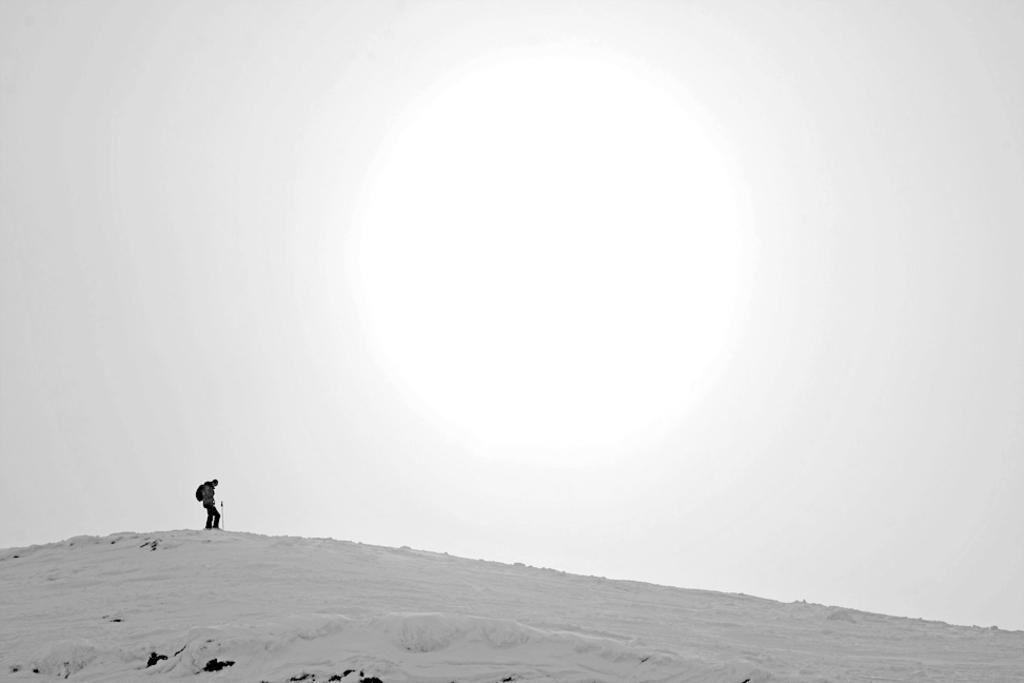Who is present in the image? There is a man in the image. Where is the man located? The man is standing on a snow mountain. What is the man carrying? The man is carrying a backpack. What can be seen at the top of the image? The sky is visible at the top of the image. What is the condition of the sky in the image? The sky appears to be clear. What direction is the porter facing in the image? There is no porter present in the image, only a man carrying a backpack. What season is depicted in the image? The image does not specify a season, but the presence of snow suggests it could be winter. 